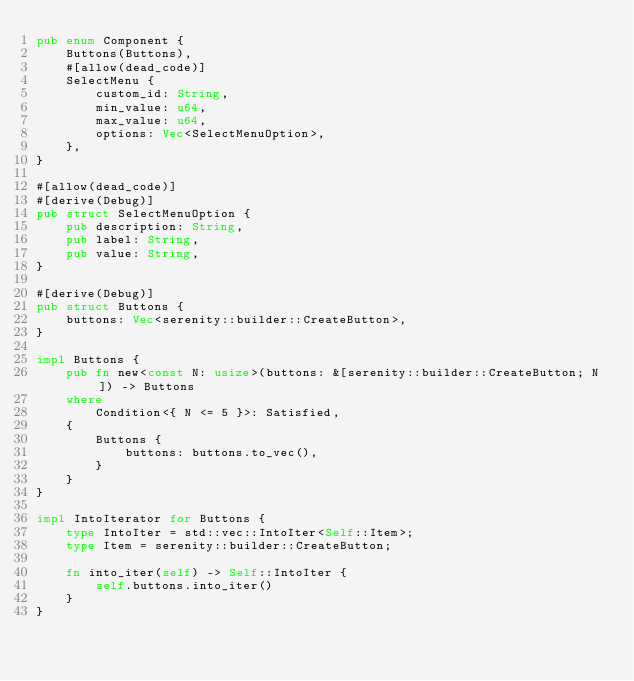<code> <loc_0><loc_0><loc_500><loc_500><_Rust_>pub enum Component {
    Buttons(Buttons),
    #[allow(dead_code)]
    SelectMenu {
        custom_id: String,
        min_value: u64,
        max_value: u64,
        options: Vec<SelectMenuOption>,
    },
}

#[allow(dead_code)]
#[derive(Debug)]
pub struct SelectMenuOption {
    pub description: String,
    pub label: String,
    pub value: String,
}

#[derive(Debug)]
pub struct Buttons {
    buttons: Vec<serenity::builder::CreateButton>,
}

impl Buttons {
    pub fn new<const N: usize>(buttons: &[serenity::builder::CreateButton; N]) -> Buttons
    where
        Condition<{ N <= 5 }>: Satisfied,
    {
        Buttons {
            buttons: buttons.to_vec(),
        }
    }
}

impl IntoIterator for Buttons {
    type IntoIter = std::vec::IntoIter<Self::Item>;
    type Item = serenity::builder::CreateButton;

    fn into_iter(self) -> Self::IntoIter {
        self.buttons.into_iter()
    }
}
</code> 